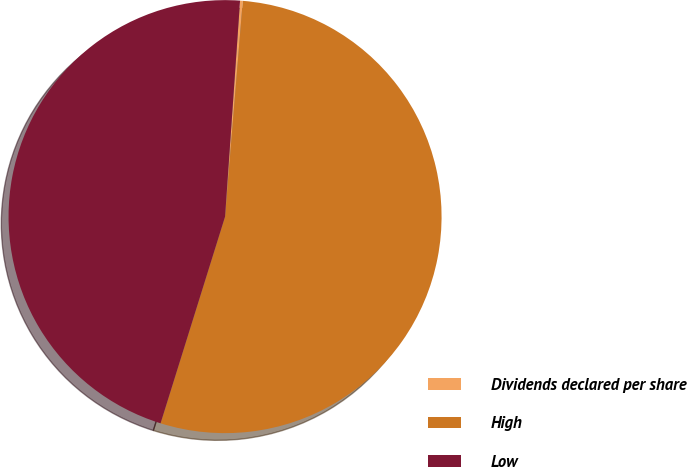<chart> <loc_0><loc_0><loc_500><loc_500><pie_chart><fcel>Dividends declared per share<fcel>High<fcel>Low<nl><fcel>0.2%<fcel>53.51%<fcel>46.29%<nl></chart> 